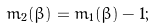Convert formula to latex. <formula><loc_0><loc_0><loc_500><loc_500>m _ { 2 } ( \beta ) = m _ { 1 } ( \beta ) - 1 ;</formula> 